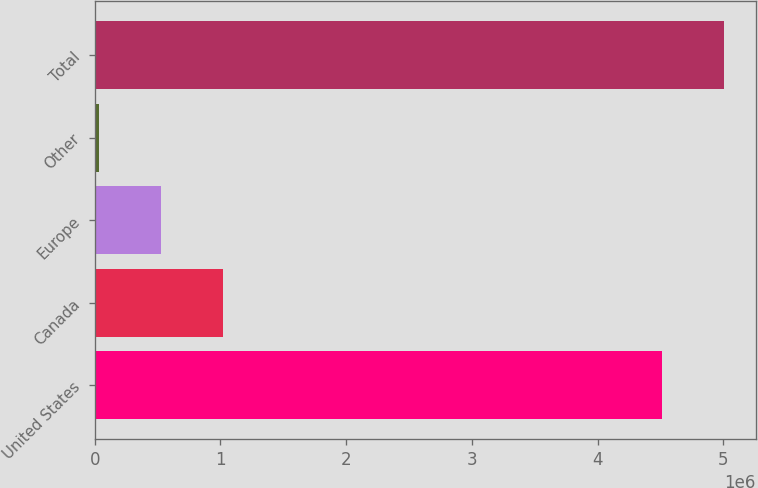Convert chart to OTSL. <chart><loc_0><loc_0><loc_500><loc_500><bar_chart><fcel>United States<fcel>Canada<fcel>Europe<fcel>Other<fcel>Total<nl><fcel>4.51281e+06<fcel>1.02009e+06<fcel>526920<fcel>33749<fcel>5.00598e+06<nl></chart> 